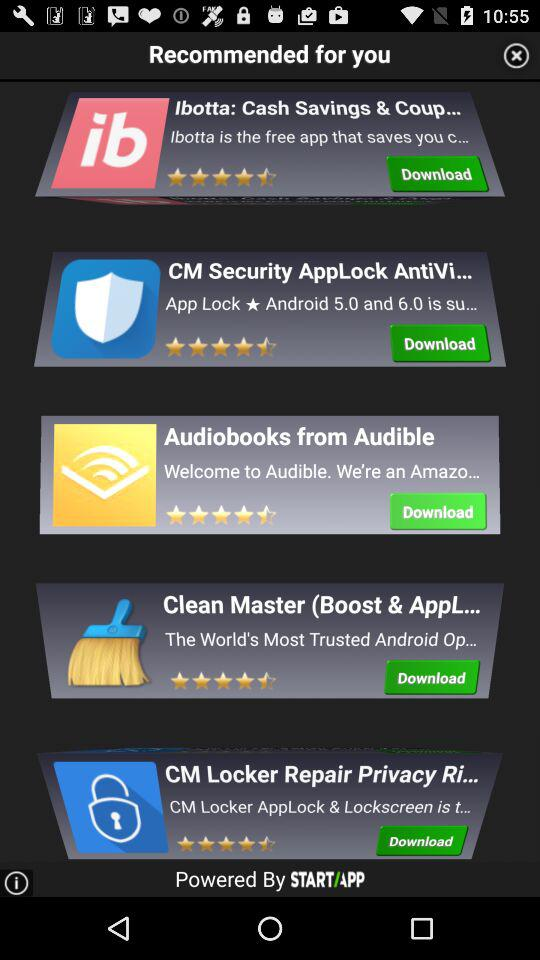What is the name of the company the applications are powered by? The name of the company the applications are powered by is "STARTAPP". 